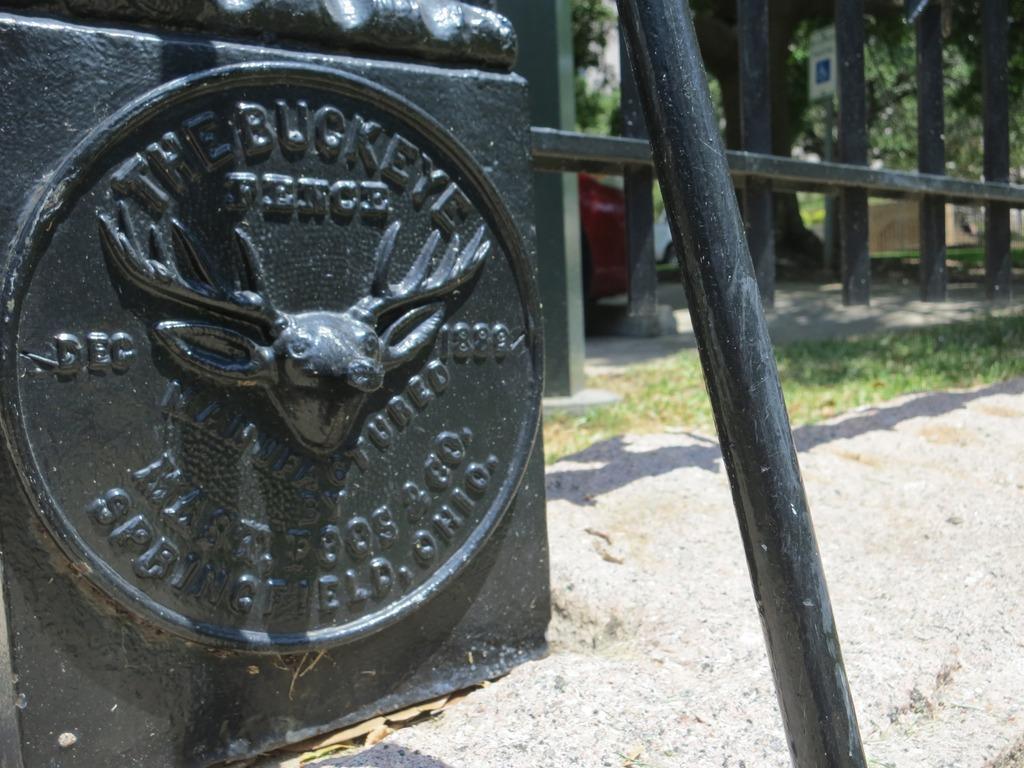Describe this image in one or two sentences. In the foreground I can see a board, metal rods, grass, fence, vehicles, trees and buildings. This image is taken may be during a sunny day. 